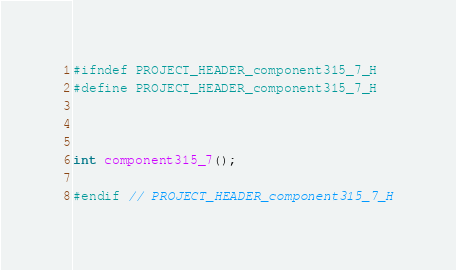<code> <loc_0><loc_0><loc_500><loc_500><_C_>#ifndef PROJECT_HEADER_component315_7_H
#define PROJECT_HEADER_component315_7_H



int component315_7();

#endif // PROJECT_HEADER_component315_7_H</code> 